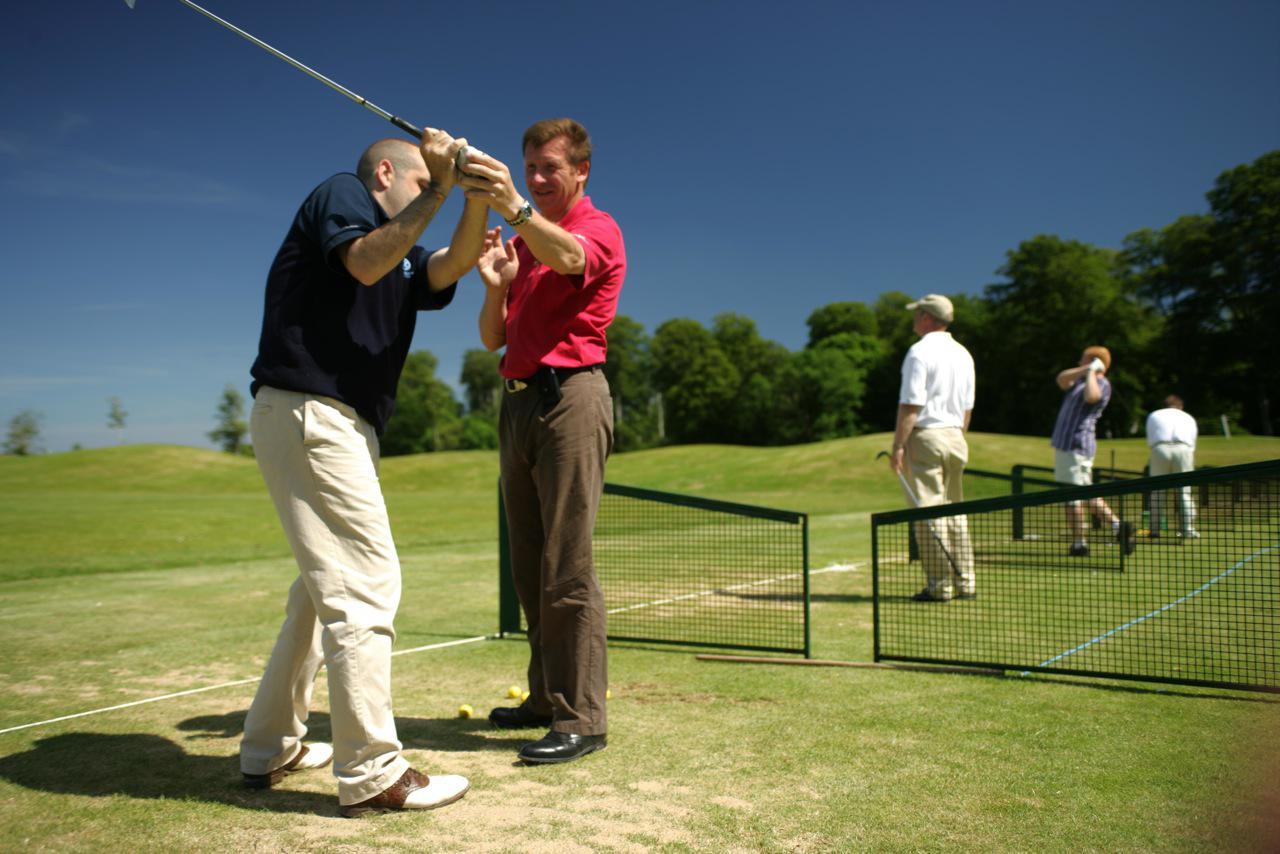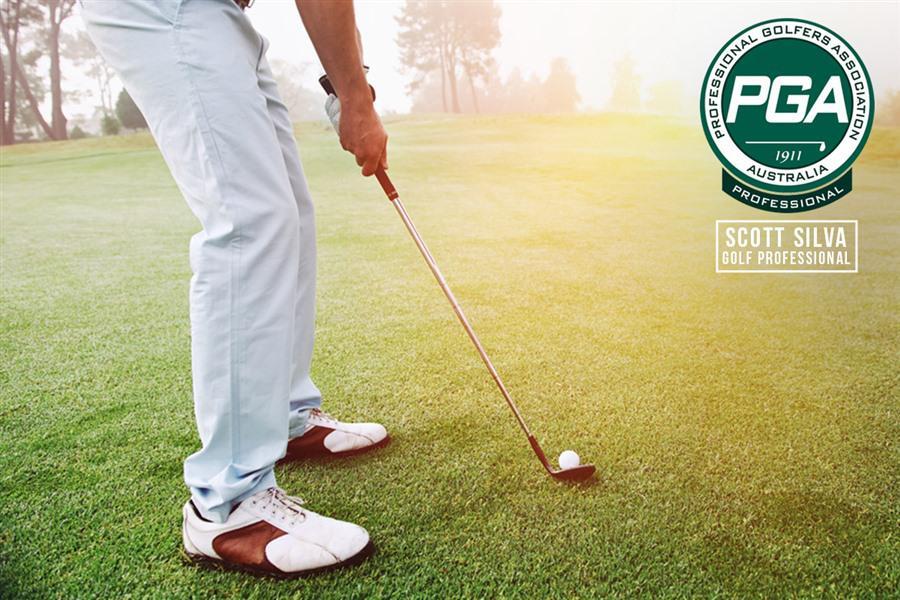The first image is the image on the left, the second image is the image on the right. Considering the images on both sides, is "The right image shows one man standing and holding a golf club next to a man crouched down beside him on a golf course" valid? Answer yes or no. No. The first image is the image on the left, the second image is the image on the right. Given the left and right images, does the statement "A man crouches in the grass to the right of a man who is standing and swinging a golf club." hold true? Answer yes or no. No. 